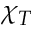<formula> <loc_0><loc_0><loc_500><loc_500>\chi _ { T }</formula> 